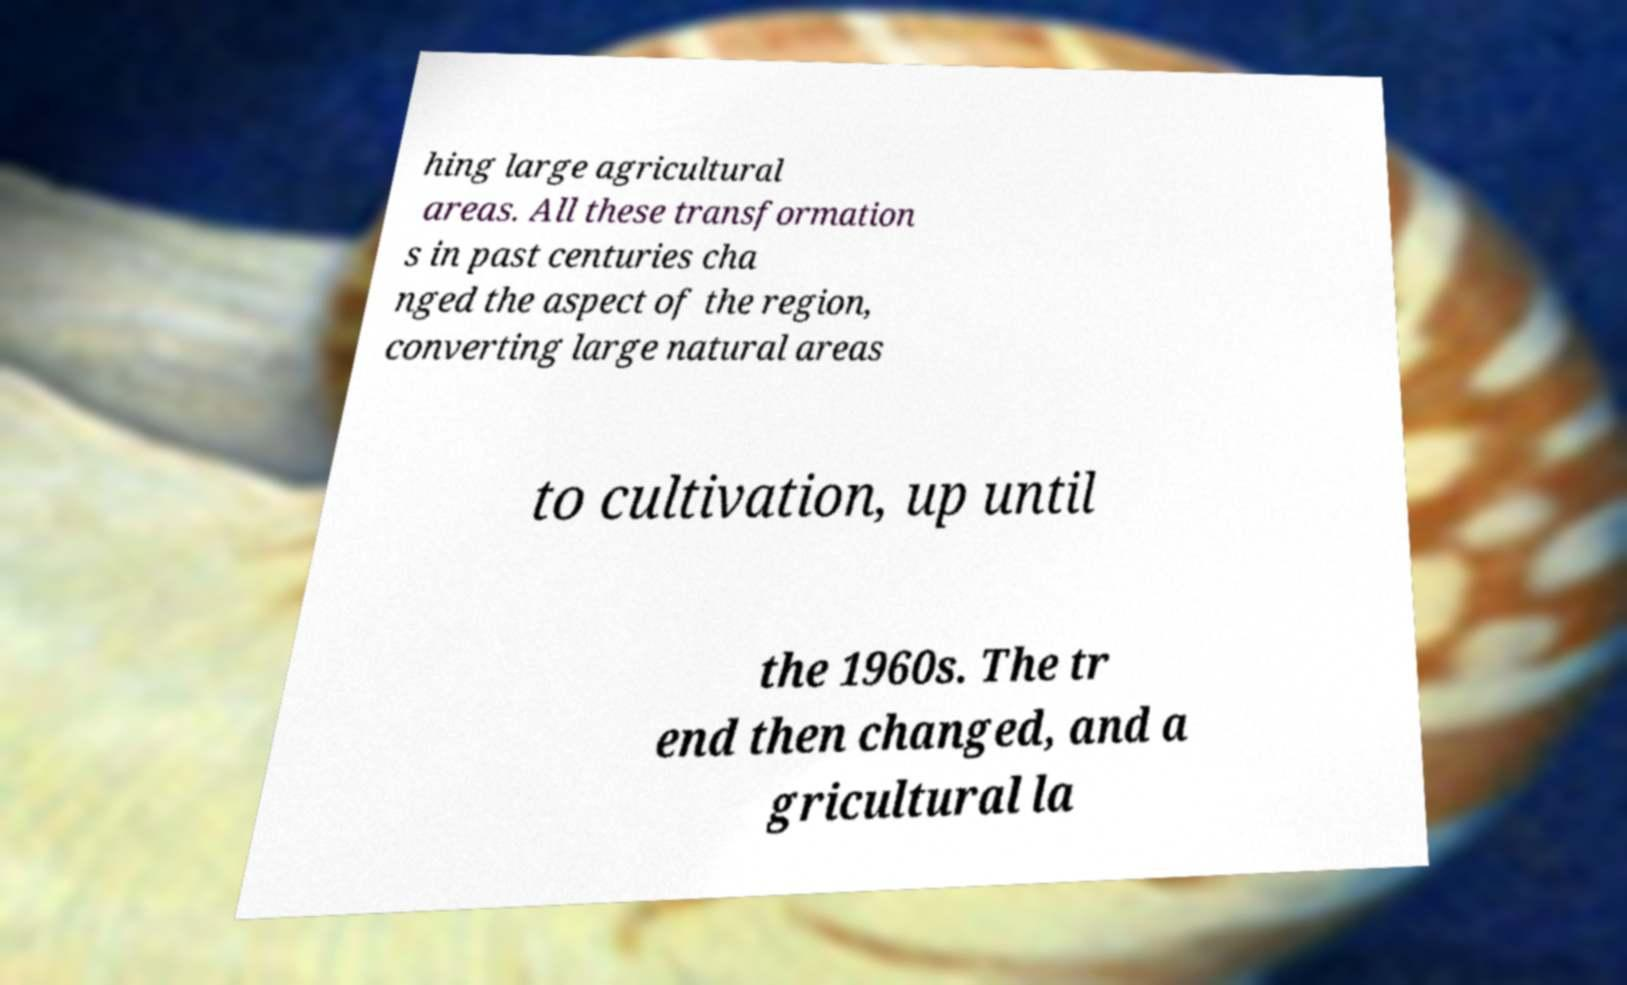Could you extract and type out the text from this image? hing large agricultural areas. All these transformation s in past centuries cha nged the aspect of the region, converting large natural areas to cultivation, up until the 1960s. The tr end then changed, and a gricultural la 